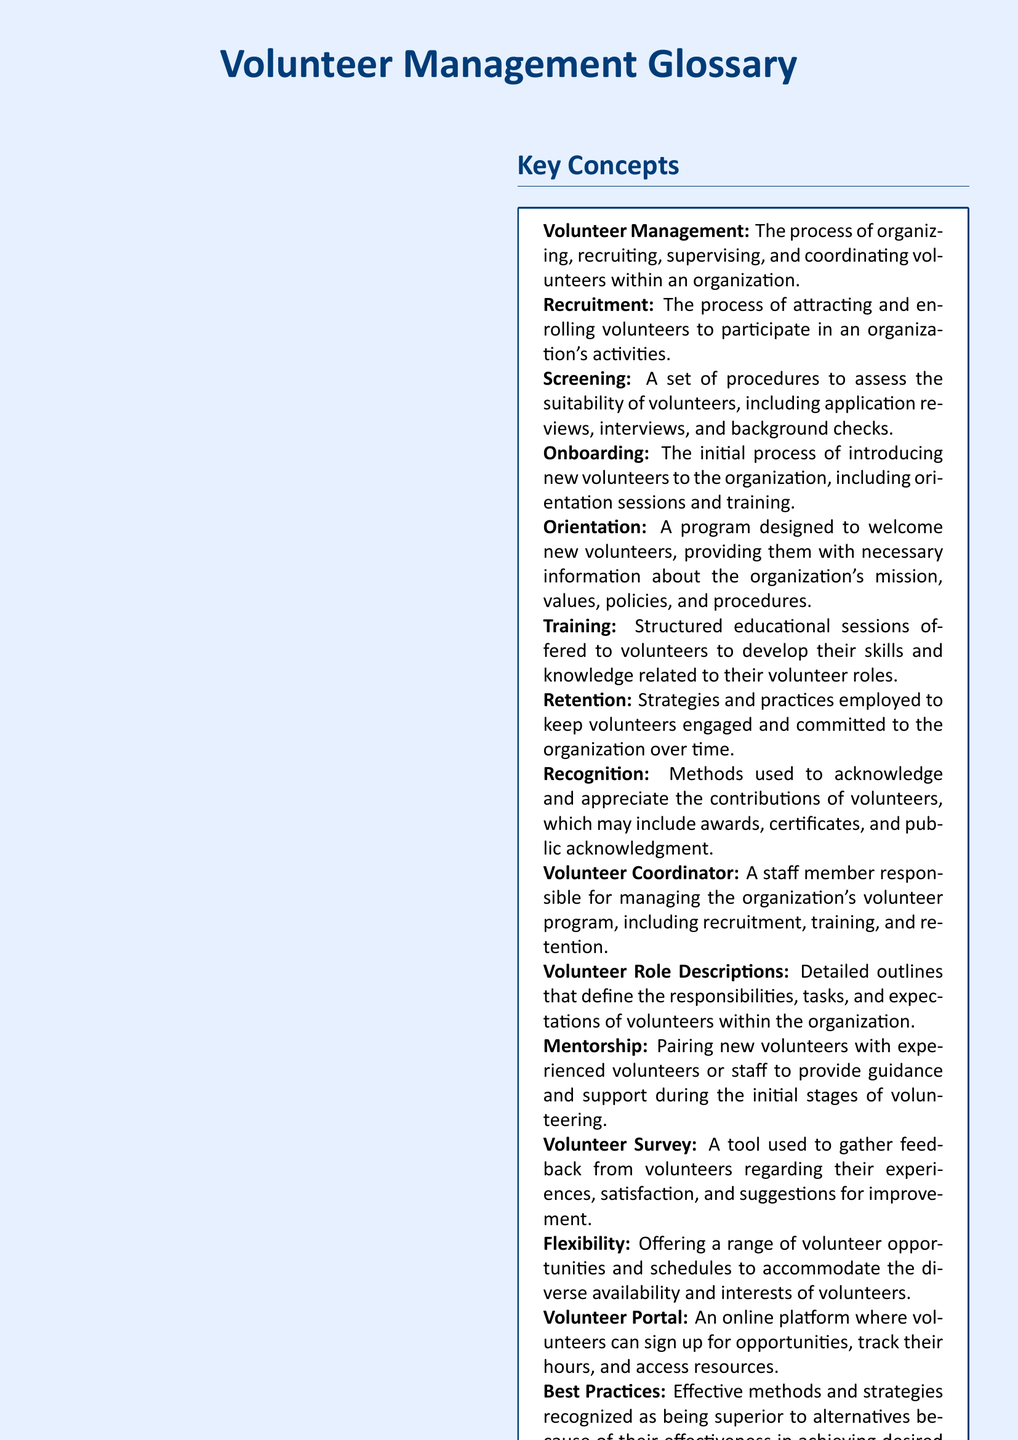What is volunteer management? Volunteer management is defined as the process of organizing, recruiting, supervising, and coordinating volunteers within an organization.
Answer: The process of organizing, recruiting, supervising, and coordinating volunteers within an organization What is the role of a volunteer coordinator? The volunteer coordinator is a staff member responsible for managing the organization's volunteer program, including recruitment, training, and retention.
Answer: A staff member responsible for managing the organization's volunteer program What is the purpose of a volunteer survey? A volunteer survey is used to gather feedback from volunteers regarding their experiences, satisfaction, and suggestions for improvement.
Answer: To gather feedback from volunteers What does retention refer to in volunteer management? Retention refers to strategies and practices employed to keep volunteers engaged and committed to the organization over time.
Answer: Strategies and practices to keep volunteers engaged What is skill-based volunteering? Skill-based volunteering leverages the specialized skills and talents of volunteers in professional areas such as IT, marketing, or legal services.
Answer: Leveraging the specialized skills and talents of volunteers 